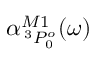Convert formula to latex. <formula><loc_0><loc_0><loc_500><loc_500>\alpha _ { \, ^ { 3 } P _ { 0 } ^ { o } } ^ { M 1 } ( \omega )</formula> 